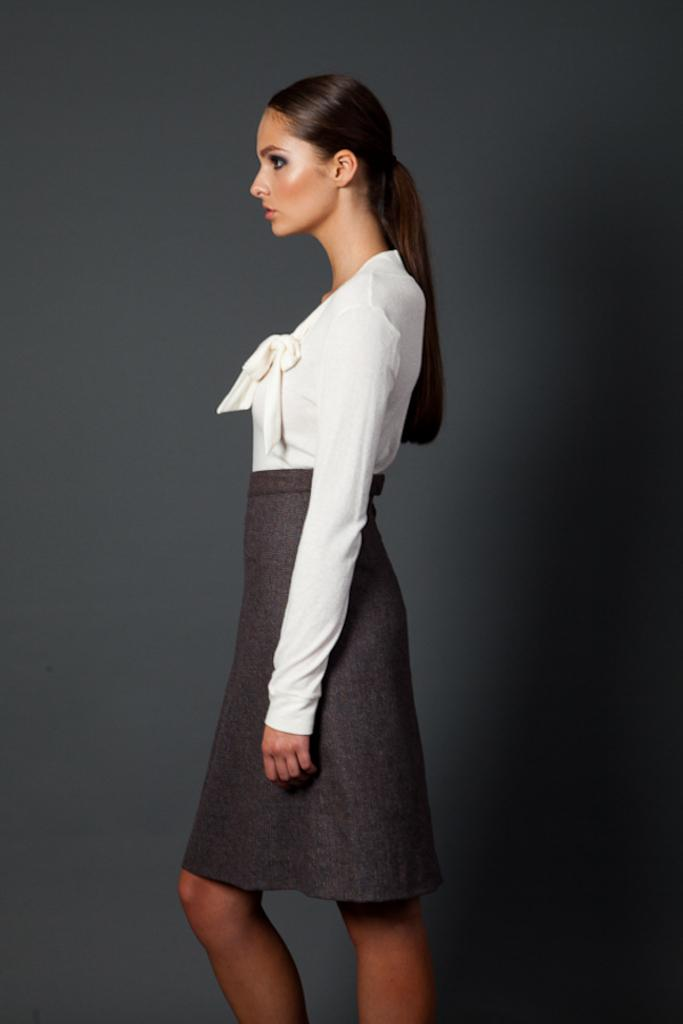What is the main subject of the image? There is a woman standing in the image. Can you describe the background of the image? The background of the image is dark. What type of baby animal is hiding behind the woman in the image? There is no baby animal present in the image; it only features a woman standing against a dark background. 